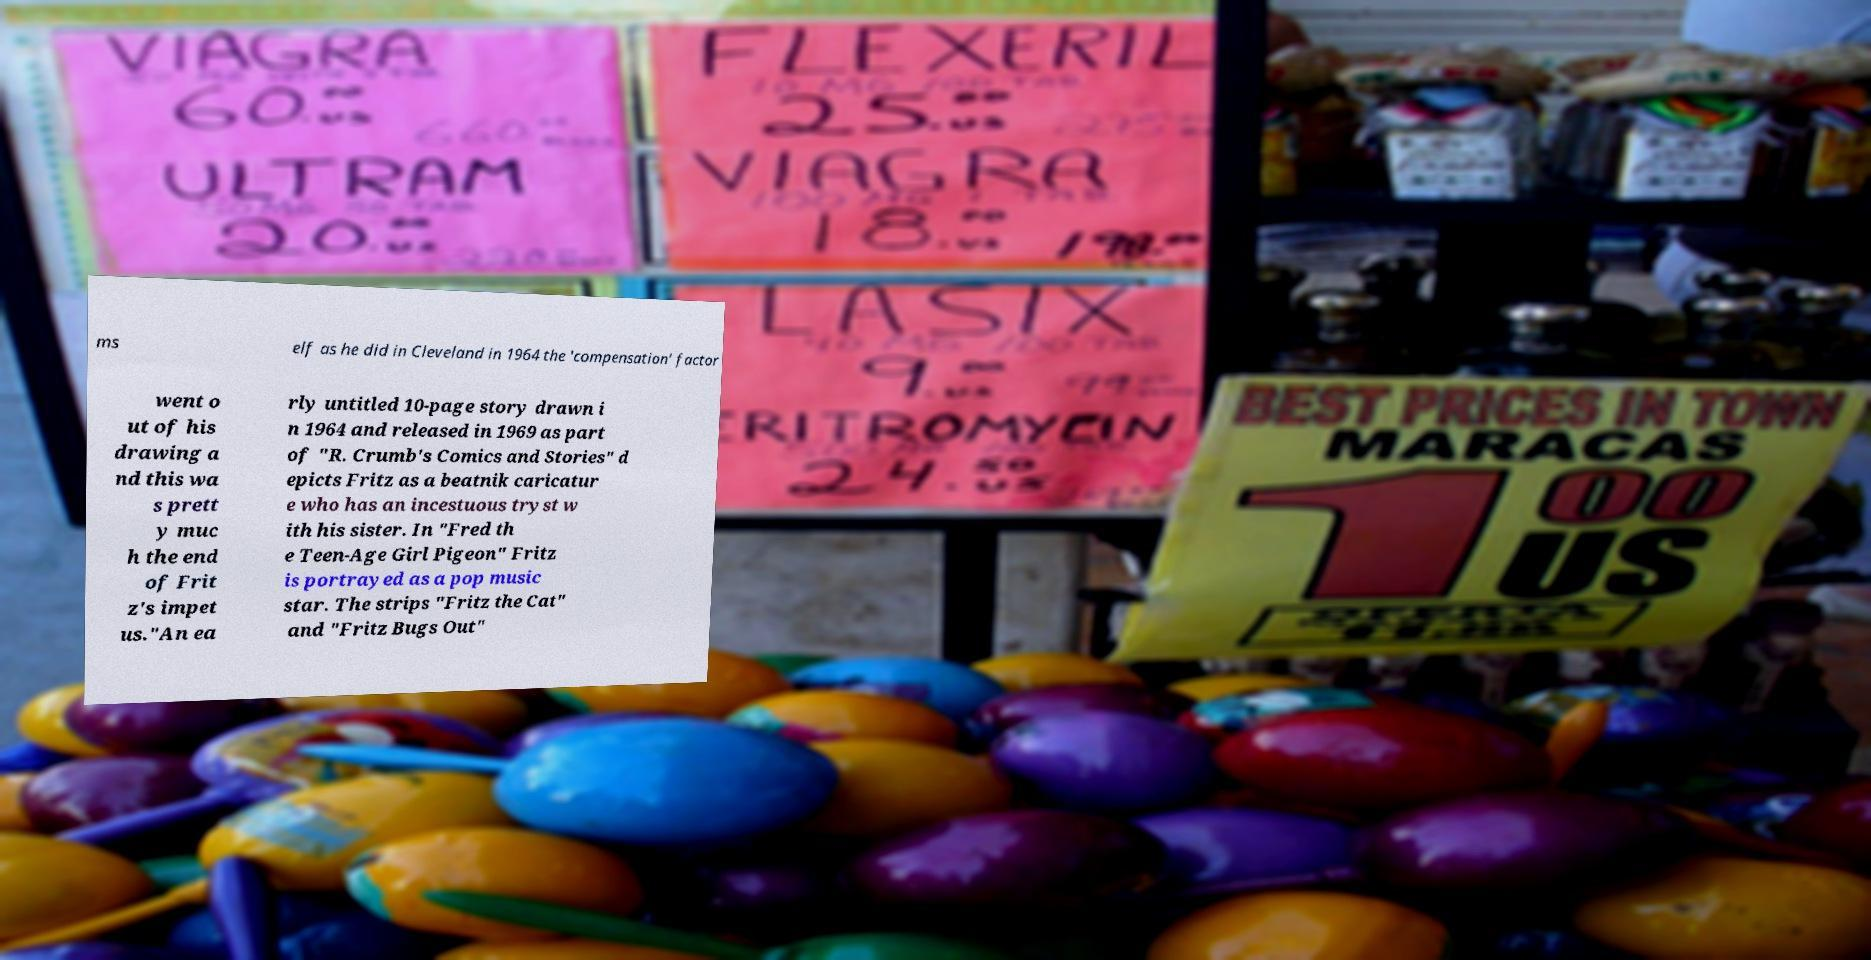Can you accurately transcribe the text from the provided image for me? ms elf as he did in Cleveland in 1964 the 'compensation' factor went o ut of his drawing a nd this wa s prett y muc h the end of Frit z's impet us."An ea rly untitled 10-page story drawn i n 1964 and released in 1969 as part of "R. Crumb's Comics and Stories" d epicts Fritz as a beatnik caricatur e who has an incestuous tryst w ith his sister. In "Fred th e Teen-Age Girl Pigeon" Fritz is portrayed as a pop music star. The strips "Fritz the Cat" and "Fritz Bugs Out" 